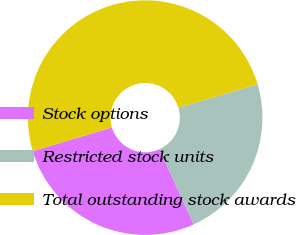Convert chart. <chart><loc_0><loc_0><loc_500><loc_500><pie_chart><fcel>Stock options<fcel>Restricted stock units<fcel>Total outstanding stock awards<nl><fcel>27.19%<fcel>22.81%<fcel>50.0%<nl></chart> 